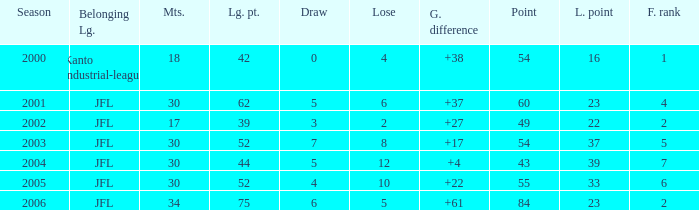Tell me the highest matches for point 43 and final rank less than 7 None. 